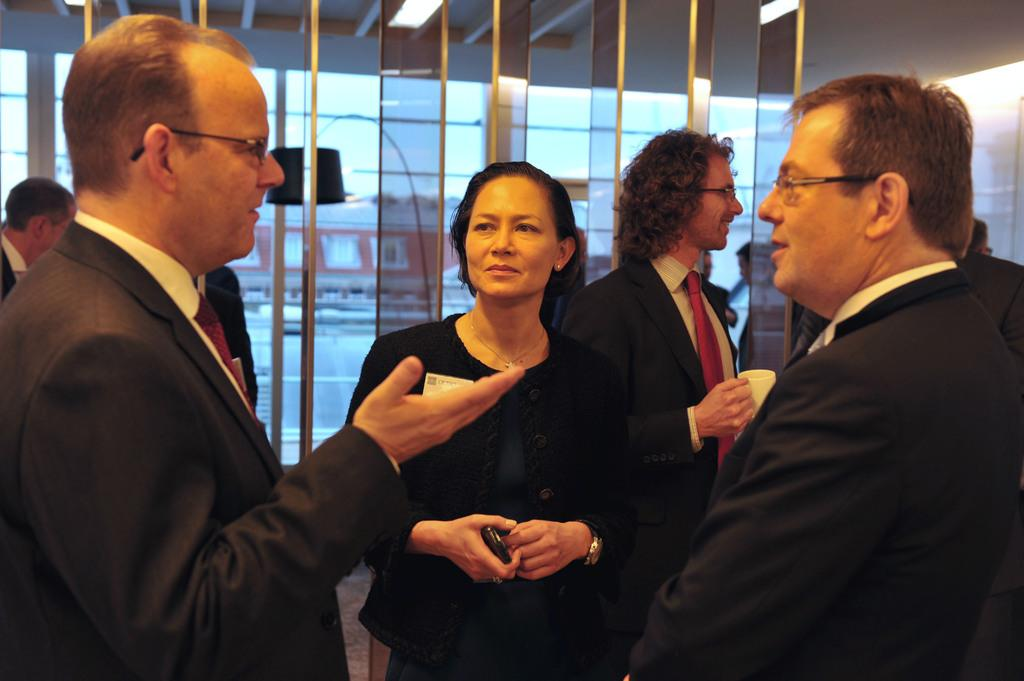How many people are in the image? There is a group of people in the image, but the exact number is not specified. What are the people in the image doing? The people are standing on the floor. Can you describe the man in the black blazer? The man in the black blazer is holding a white cup. What else can be seen behind the people in the image? There are glasses visible behind the people. What type of cake is being divided among the people in the image? There is no cake present in the image, nor is there any indication of division or sharing among the people. 